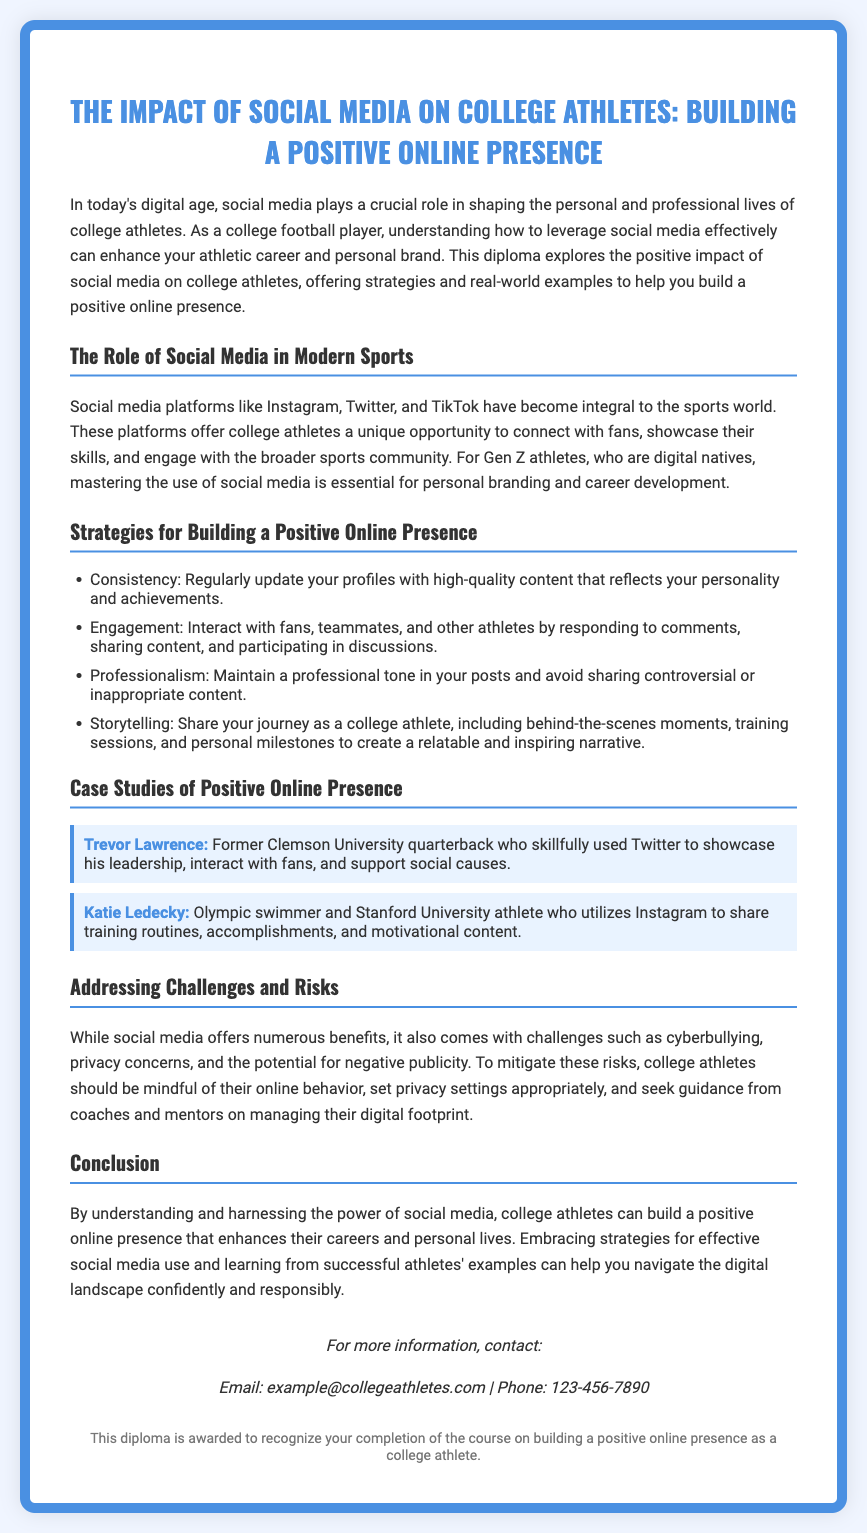what is the title of the diploma? The title is explicitly mentioned at the top of the document.
Answer: The Impact of Social Media on College Athletes: Building a Positive Online Presence who is a case study mentioned in the document? The document lists specific athletes as examples in the case studies section.
Answer: Trevor Lawrence what is one strategy for building a positive online presence? The document lists several strategies in a bulleted format under the corresponding section.
Answer: Consistency which social media platforms are highlighted in the document? The document mentions specific social media platforms in the context of college athletes' engagement.
Answer: Instagram, Twitter, and TikTok what is a challenge mentioned regarding social media use for athletes? The document identifies challenges associated with the use of social media for college athletes.
Answer: Cyberbullying what should college athletes do to mitigate risks on social media? The document provides guidance on managing online behavior and risks.
Answer: Set privacy settings appropriately why is understanding social media important for college athletes? The document discusses the impact of social media on professional lives and branding for athletes.
Answer: To enhance their athletic career and personal brand how is the document structured? The document includes specific sections that are organized to present information clearly.
Answer: Diploma format with sections and case studies 